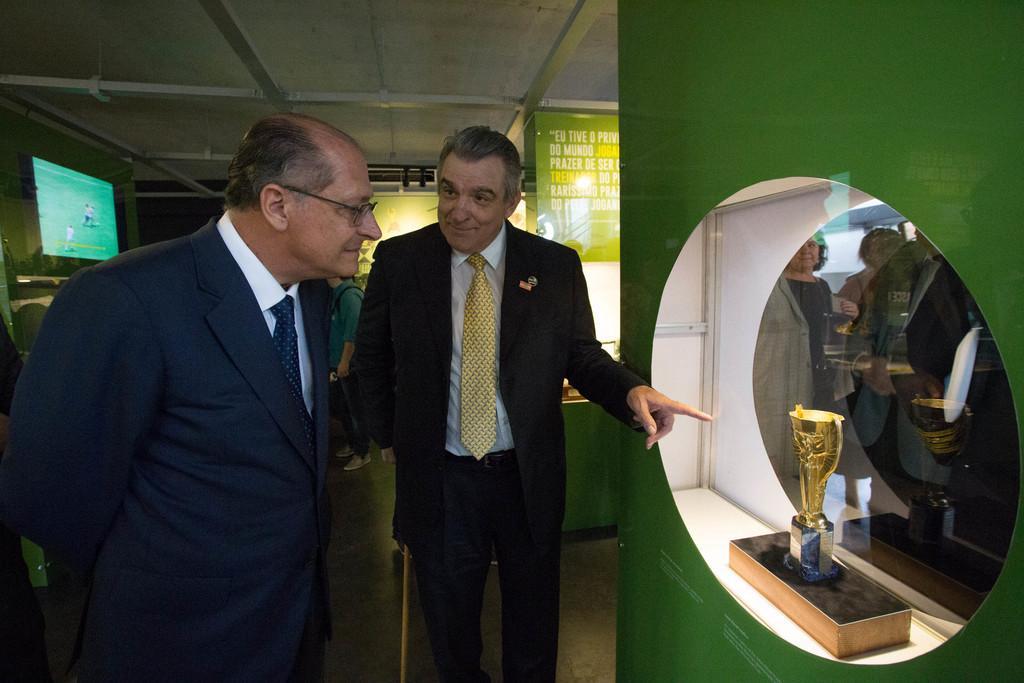Could you give a brief overview of what you see in this image? In this picture there are people standing. There is a cup which is kept on the shelf on the right side and there are banners with some text written on the banners. In the front there are two persons standing and smiling. On the right side behind the the glass there are persons standing. On the left side there is a TV which is on. On the top there are white colour objects. 